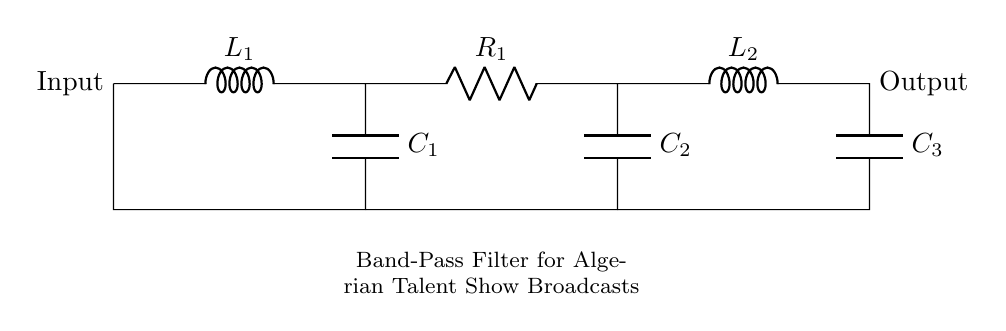What type of filter is depicted in this circuit diagram? The circuit diagram represents a band-pass filter, which is specifically designed to allow signals within a certain frequency range to pass while attenuating frequencies outside that range. The presence of inductors and capacitors indicates that it is filtering specific frequency components.
Answer: band-pass filter How many capacitors are used in the circuit? The diagram features three capacitors labeled as C1, C2, and C3. Count the symbols in the circuit to determine the number of capacitors: one at the beginning and two further down in the circuit.
Answer: three What are the components used in the filter circuit? The components visible in the circuit diagram include inductors, capacitors, and a resistor. By identifying each symbol in the diagram and their labels (L1, L2, C1, C2, C3, and R1), we can list all the components present.
Answer: inductors, capacitors, resistor Why would a band-pass filter be useful for isolating radio broadcasts? A band-pass filter allows only a specific range of frequencies to be transmitted while blocking others. This is particularly useful for radio broadcasts to minimize interference from other signals and to focus on the desired broadcast frequency, enhancing the clarity of local talent shows.
Answer: to minimize interference What is the role of the resistor in this circuit? The resistor in the circuit, labeled R1, serves to control the impedance in the filter configuration. It can help to stabilize the circuit and dictate the bandwidth and levels of attenuation for certain freqencies, working alongside the capacitors and inductors to maintain the desired filtering effect.
Answer: control impedance What does the output of the filter circuit represent? The output of the filter circuit, indicated in the diagram, represents the filtered signal after the original input has passed through the filtering components. Therefore, it will contain only the frequencies that lie within the selected band, which is essential for focusing on specific broadcasts.
Answer: filtered signal 